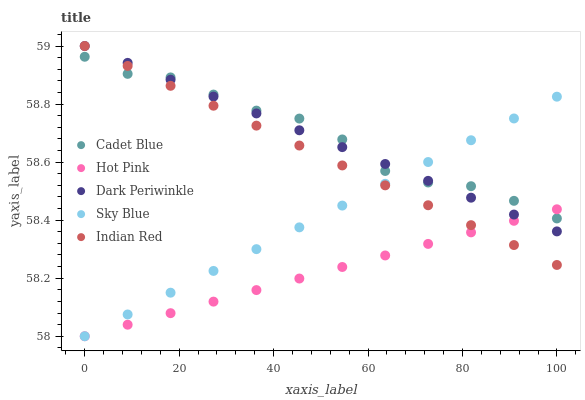Does Hot Pink have the minimum area under the curve?
Answer yes or no. Yes. Does Cadet Blue have the maximum area under the curve?
Answer yes or no. Yes. Does Dark Periwinkle have the minimum area under the curve?
Answer yes or no. No. Does Dark Periwinkle have the maximum area under the curve?
Answer yes or no. No. Is Sky Blue the smoothest?
Answer yes or no. Yes. Is Cadet Blue the roughest?
Answer yes or no. Yes. Is Dark Periwinkle the smoothest?
Answer yes or no. No. Is Dark Periwinkle the roughest?
Answer yes or no. No. Does Sky Blue have the lowest value?
Answer yes or no. Yes. Does Dark Periwinkle have the lowest value?
Answer yes or no. No. Does Indian Red have the highest value?
Answer yes or no. Yes. Does Cadet Blue have the highest value?
Answer yes or no. No. Does Hot Pink intersect Indian Red?
Answer yes or no. Yes. Is Hot Pink less than Indian Red?
Answer yes or no. No. Is Hot Pink greater than Indian Red?
Answer yes or no. No. 